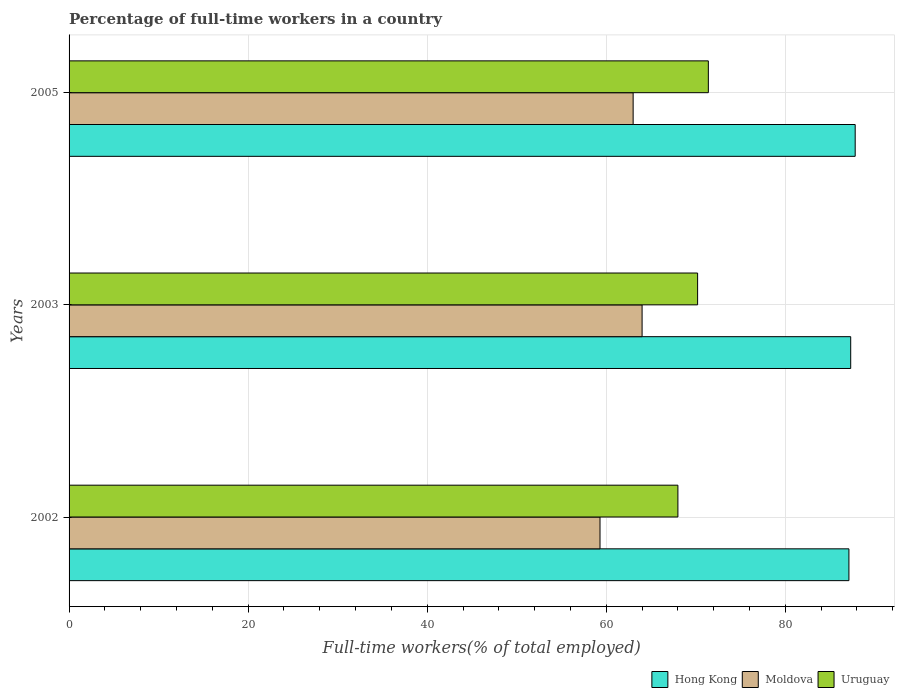How many bars are there on the 1st tick from the top?
Provide a short and direct response. 3. What is the label of the 3rd group of bars from the top?
Offer a terse response. 2002. In how many cases, is the number of bars for a given year not equal to the number of legend labels?
Keep it short and to the point. 0. What is the percentage of full-time workers in Moldova in 2002?
Keep it short and to the point. 59.3. Across all years, what is the maximum percentage of full-time workers in Hong Kong?
Give a very brief answer. 87.8. Across all years, what is the minimum percentage of full-time workers in Hong Kong?
Make the answer very short. 87.1. What is the total percentage of full-time workers in Uruguay in the graph?
Your answer should be very brief. 209.6. What is the difference between the percentage of full-time workers in Hong Kong in 2002 and that in 2005?
Your response must be concise. -0.7. What is the difference between the percentage of full-time workers in Uruguay in 2003 and the percentage of full-time workers in Moldova in 2002?
Offer a terse response. 10.9. What is the average percentage of full-time workers in Moldova per year?
Provide a short and direct response. 62.1. In the year 2003, what is the difference between the percentage of full-time workers in Uruguay and percentage of full-time workers in Hong Kong?
Provide a short and direct response. -17.1. What is the ratio of the percentage of full-time workers in Uruguay in 2003 to that in 2005?
Make the answer very short. 0.98. Is the difference between the percentage of full-time workers in Uruguay in 2002 and 2003 greater than the difference between the percentage of full-time workers in Hong Kong in 2002 and 2003?
Your response must be concise. No. What is the difference between the highest and the second highest percentage of full-time workers in Hong Kong?
Your answer should be very brief. 0.5. What is the difference between the highest and the lowest percentage of full-time workers in Uruguay?
Your answer should be very brief. 3.4. Is the sum of the percentage of full-time workers in Moldova in 2002 and 2003 greater than the maximum percentage of full-time workers in Hong Kong across all years?
Your response must be concise. Yes. What does the 3rd bar from the top in 2002 represents?
Make the answer very short. Hong Kong. What does the 1st bar from the bottom in 2002 represents?
Offer a terse response. Hong Kong. How many bars are there?
Offer a very short reply. 9. What is the difference between two consecutive major ticks on the X-axis?
Provide a short and direct response. 20. Does the graph contain any zero values?
Provide a short and direct response. No. Does the graph contain grids?
Keep it short and to the point. Yes. Where does the legend appear in the graph?
Your answer should be compact. Bottom right. How many legend labels are there?
Your answer should be compact. 3. How are the legend labels stacked?
Provide a short and direct response. Horizontal. What is the title of the graph?
Your answer should be compact. Percentage of full-time workers in a country. What is the label or title of the X-axis?
Ensure brevity in your answer.  Full-time workers(% of total employed). What is the label or title of the Y-axis?
Your answer should be very brief. Years. What is the Full-time workers(% of total employed) in Hong Kong in 2002?
Keep it short and to the point. 87.1. What is the Full-time workers(% of total employed) of Moldova in 2002?
Ensure brevity in your answer.  59.3. What is the Full-time workers(% of total employed) of Uruguay in 2002?
Your answer should be very brief. 68. What is the Full-time workers(% of total employed) of Hong Kong in 2003?
Your response must be concise. 87.3. What is the Full-time workers(% of total employed) in Uruguay in 2003?
Provide a short and direct response. 70.2. What is the Full-time workers(% of total employed) of Hong Kong in 2005?
Give a very brief answer. 87.8. What is the Full-time workers(% of total employed) of Moldova in 2005?
Keep it short and to the point. 63. What is the Full-time workers(% of total employed) in Uruguay in 2005?
Offer a terse response. 71.4. Across all years, what is the maximum Full-time workers(% of total employed) in Hong Kong?
Give a very brief answer. 87.8. Across all years, what is the maximum Full-time workers(% of total employed) of Uruguay?
Provide a short and direct response. 71.4. Across all years, what is the minimum Full-time workers(% of total employed) of Hong Kong?
Give a very brief answer. 87.1. Across all years, what is the minimum Full-time workers(% of total employed) of Moldova?
Keep it short and to the point. 59.3. What is the total Full-time workers(% of total employed) in Hong Kong in the graph?
Make the answer very short. 262.2. What is the total Full-time workers(% of total employed) in Moldova in the graph?
Give a very brief answer. 186.3. What is the total Full-time workers(% of total employed) of Uruguay in the graph?
Keep it short and to the point. 209.6. What is the difference between the Full-time workers(% of total employed) of Hong Kong in 2002 and that in 2003?
Your answer should be very brief. -0.2. What is the difference between the Full-time workers(% of total employed) of Hong Kong in 2002 and that in 2005?
Provide a short and direct response. -0.7. What is the difference between the Full-time workers(% of total employed) of Moldova in 2002 and that in 2005?
Ensure brevity in your answer.  -3.7. What is the difference between the Full-time workers(% of total employed) of Uruguay in 2002 and that in 2005?
Your response must be concise. -3.4. What is the difference between the Full-time workers(% of total employed) in Hong Kong in 2002 and the Full-time workers(% of total employed) in Moldova in 2003?
Keep it short and to the point. 23.1. What is the difference between the Full-time workers(% of total employed) in Hong Kong in 2002 and the Full-time workers(% of total employed) in Moldova in 2005?
Ensure brevity in your answer.  24.1. What is the difference between the Full-time workers(% of total employed) in Moldova in 2002 and the Full-time workers(% of total employed) in Uruguay in 2005?
Your answer should be very brief. -12.1. What is the difference between the Full-time workers(% of total employed) of Hong Kong in 2003 and the Full-time workers(% of total employed) of Moldova in 2005?
Offer a very short reply. 24.3. What is the difference between the Full-time workers(% of total employed) of Moldova in 2003 and the Full-time workers(% of total employed) of Uruguay in 2005?
Ensure brevity in your answer.  -7.4. What is the average Full-time workers(% of total employed) of Hong Kong per year?
Give a very brief answer. 87.4. What is the average Full-time workers(% of total employed) of Moldova per year?
Give a very brief answer. 62.1. What is the average Full-time workers(% of total employed) in Uruguay per year?
Your answer should be compact. 69.87. In the year 2002, what is the difference between the Full-time workers(% of total employed) of Hong Kong and Full-time workers(% of total employed) of Moldova?
Make the answer very short. 27.8. In the year 2002, what is the difference between the Full-time workers(% of total employed) of Moldova and Full-time workers(% of total employed) of Uruguay?
Ensure brevity in your answer.  -8.7. In the year 2003, what is the difference between the Full-time workers(% of total employed) of Hong Kong and Full-time workers(% of total employed) of Moldova?
Your response must be concise. 23.3. In the year 2003, what is the difference between the Full-time workers(% of total employed) in Moldova and Full-time workers(% of total employed) in Uruguay?
Provide a short and direct response. -6.2. In the year 2005, what is the difference between the Full-time workers(% of total employed) in Hong Kong and Full-time workers(% of total employed) in Moldova?
Your response must be concise. 24.8. In the year 2005, what is the difference between the Full-time workers(% of total employed) in Hong Kong and Full-time workers(% of total employed) in Uruguay?
Your answer should be very brief. 16.4. What is the ratio of the Full-time workers(% of total employed) of Moldova in 2002 to that in 2003?
Make the answer very short. 0.93. What is the ratio of the Full-time workers(% of total employed) in Uruguay in 2002 to that in 2003?
Offer a terse response. 0.97. What is the ratio of the Full-time workers(% of total employed) of Moldova in 2002 to that in 2005?
Offer a terse response. 0.94. What is the ratio of the Full-time workers(% of total employed) of Hong Kong in 2003 to that in 2005?
Give a very brief answer. 0.99. What is the ratio of the Full-time workers(% of total employed) in Moldova in 2003 to that in 2005?
Give a very brief answer. 1.02. What is the ratio of the Full-time workers(% of total employed) of Uruguay in 2003 to that in 2005?
Offer a very short reply. 0.98. What is the difference between the highest and the second highest Full-time workers(% of total employed) of Hong Kong?
Provide a short and direct response. 0.5. What is the difference between the highest and the second highest Full-time workers(% of total employed) of Moldova?
Offer a very short reply. 1. What is the difference between the highest and the lowest Full-time workers(% of total employed) of Hong Kong?
Provide a short and direct response. 0.7. 